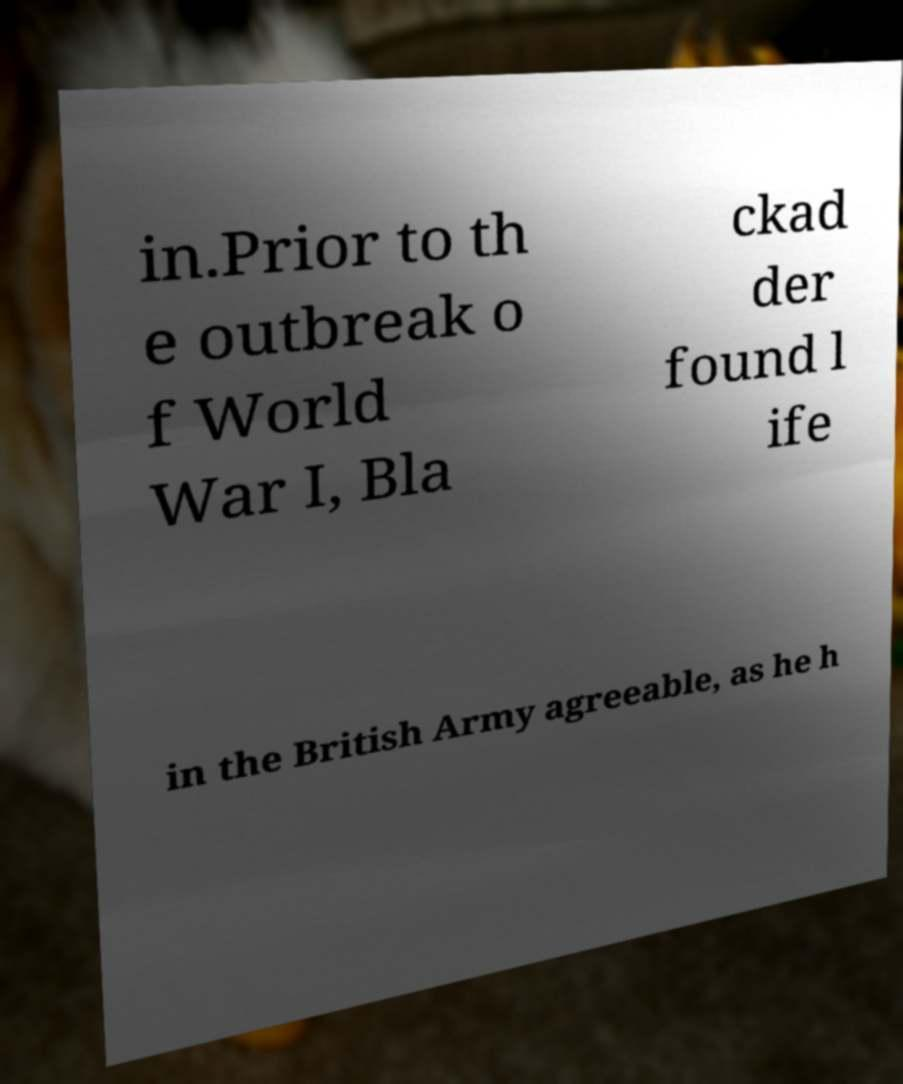I need the written content from this picture converted into text. Can you do that? in.Prior to th e outbreak o f World War I, Bla ckad der found l ife in the British Army agreeable, as he h 